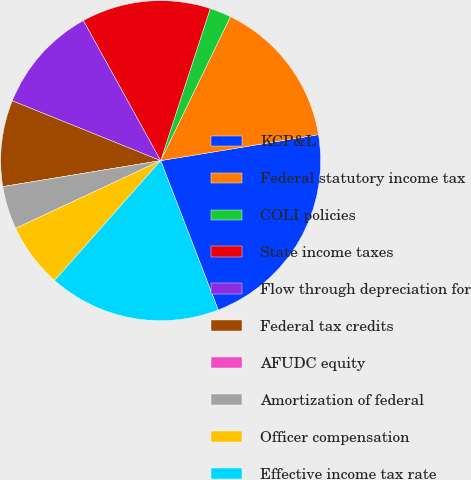Convert chart. <chart><loc_0><loc_0><loc_500><loc_500><pie_chart><fcel>KCP&L<fcel>Federal statutory income tax<fcel>COLI policies<fcel>State income taxes<fcel>Flow through depreciation for<fcel>Federal tax credits<fcel>AFUDC equity<fcel>Amortization of federal<fcel>Officer compensation<fcel>Effective income tax rate<nl><fcel>21.74%<fcel>15.22%<fcel>2.17%<fcel>13.04%<fcel>10.87%<fcel>8.7%<fcel>0.0%<fcel>4.35%<fcel>6.52%<fcel>17.39%<nl></chart> 